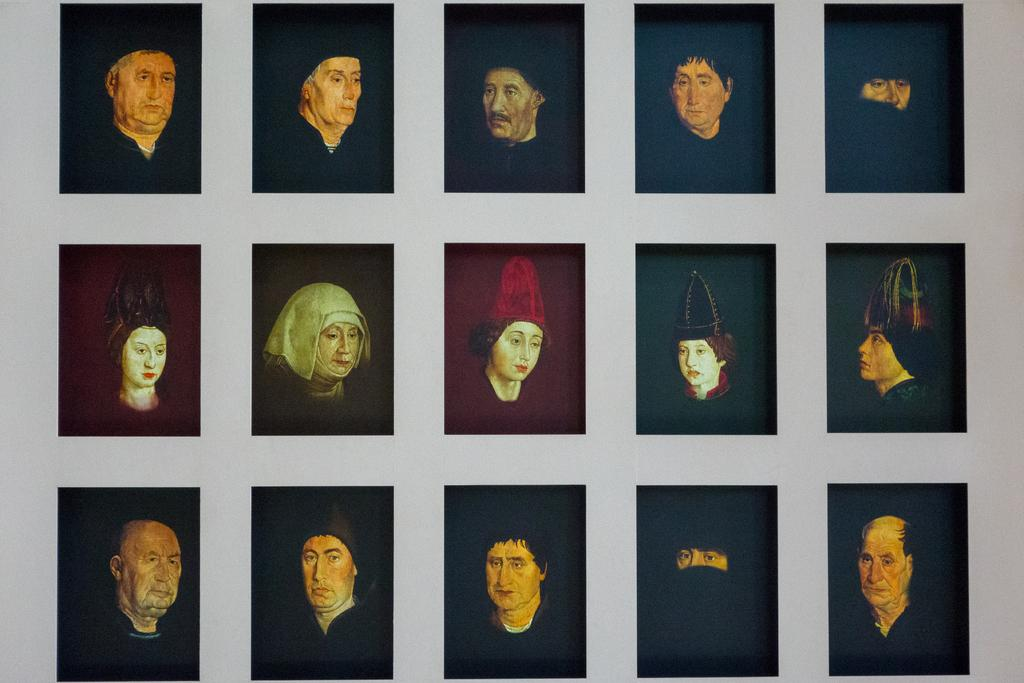What is on the white wall in the image? There are frames on the white wall. What can be seen inside the frames? There are people visible in the frames. How much soap is needed to clean the frames in the image? There is no soap present in the image, as the frames are not dirty or in need of cleaning. 